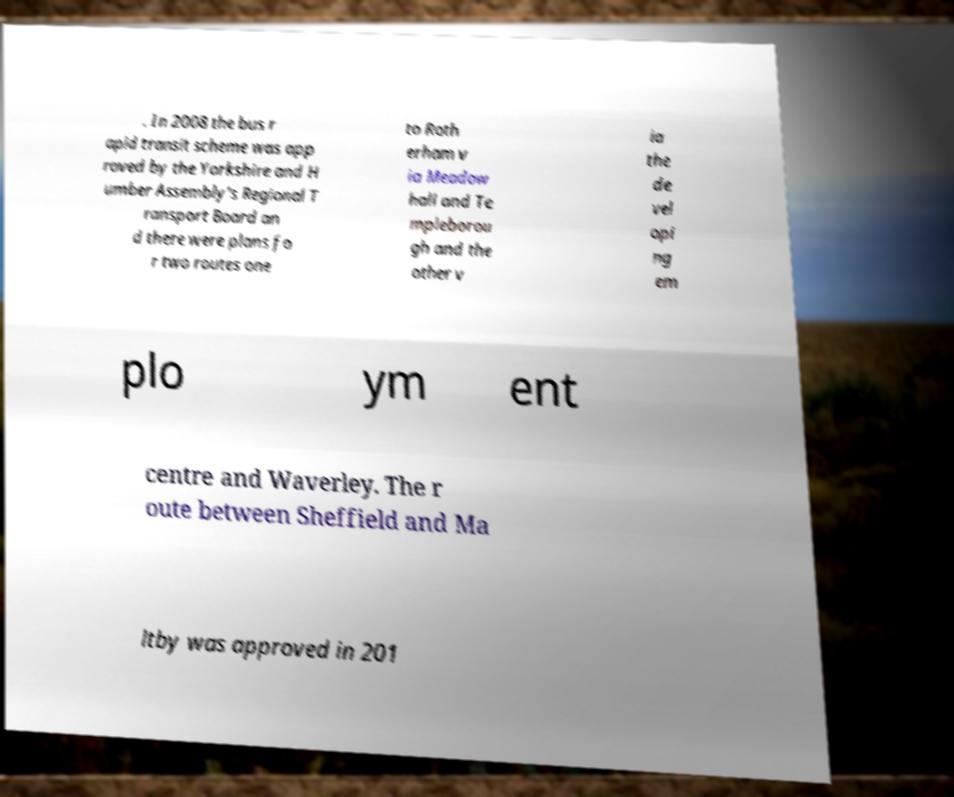There's text embedded in this image that I need extracted. Can you transcribe it verbatim? . In 2008 the bus r apid transit scheme was app roved by the Yorkshire and H umber Assembly's Regional T ransport Board an d there were plans fo r two routes one to Roth erham v ia Meadow hall and Te mpleborou gh and the other v ia the de vel opi ng em plo ym ent centre and Waverley. The r oute between Sheffield and Ma ltby was approved in 201 